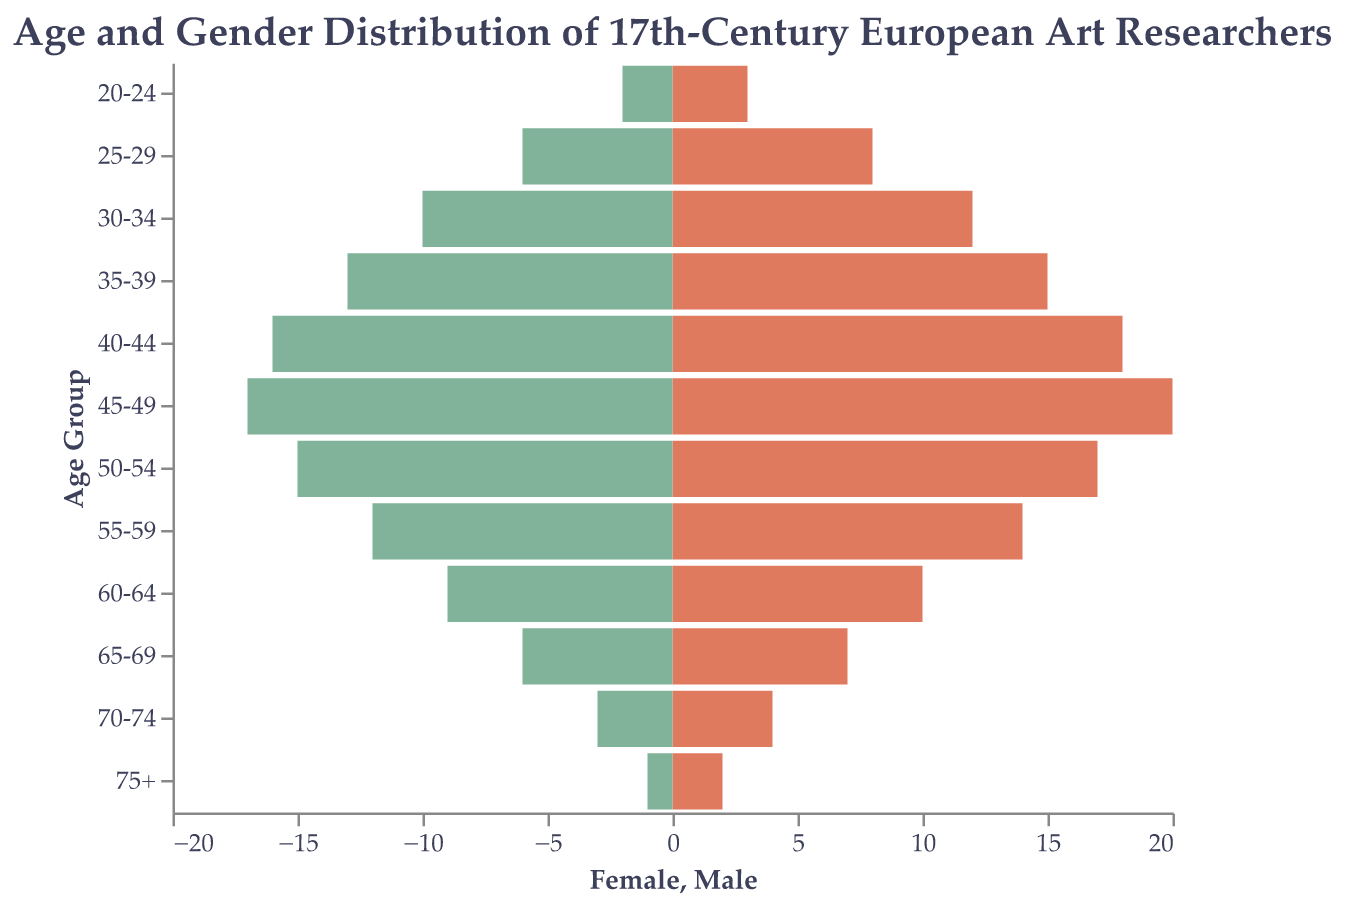What is the title of the figure? The title of the figure can be found at the top of the chart area. It reads: "Age and Gender Distribution of 17th-Century European Art Researchers".
Answer: Age and Gender Distribution of 17th-Century European Art Researchers What are the axis labels for the bars representing females and males? The axis label for the bars representing females is "Female" and for the bars representing males is "Male". These can be found on the horizontal axes, with "Female" on the right side and "Male" on the left side.
Answer: Female, Male In what age group is the number of female researchers the highest? The highest bar for female researchers indicates that the age group with the most female researchers is "45-49".
Answer: 45-49 How many male researchers are there in the "30-34" age group? To find the number of male researchers in the "30-34" age group, look for the left bar corresponding to this age group. The count is given as 10.
Answer: 10 Compare the number of female researchers in the "40-44" age group to the number of male researchers in the same age group. What is the difference? The number of female researchers is 18 and the number of male researchers is 16. The difference between the two numbers is 18 - 16 = 2.
Answer: 2 Which age group has more male researchers than female researchers? By comparing the lengths of the bars across age groups, we see that in none of the age groups do the male researchers exceed the number of female researchers.
Answer: None What is the total number of female researchers in the age groups 60+? Add the numbers of female researchers in age groups "60-64", "65-69", "70-74", and "75+" which are 10, 7, 4, and 2 respectively to get the total: 10 + 7 + 4 + 2 = 23.
Answer: 23 Between which age groups do the number of female researchers sharply decline after reaching a peak? The number of female researchers peaks at the age group "45-49" with 20 researchers. The next age group, "50-54", shows a decrease to 17 researchers, indicating a sharp decline.
Answer: 45-49 to 50-54 What is the general trend of the number of researchers as age increases? Observing the overall shape of the pyramid, the number of researchers generally increases from younger age groups, peaks around the middle age groups (35-49), and then decreases again as age continues to increase.
Answer: Increase, peak, decrease What is the ratio of male to female researchers in the "50-54" age group? The number of male researchers in the "50-54" age group is 15, and the number of female researchers is 17. The ratio is 15:17.
Answer: 15:17 